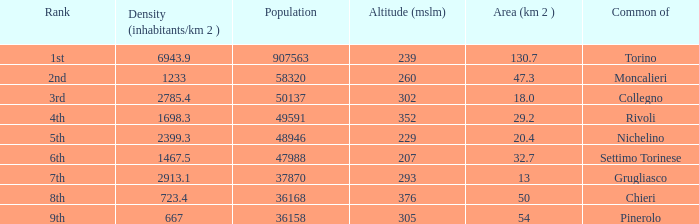The common of Chieri has what population density? 723.4. 